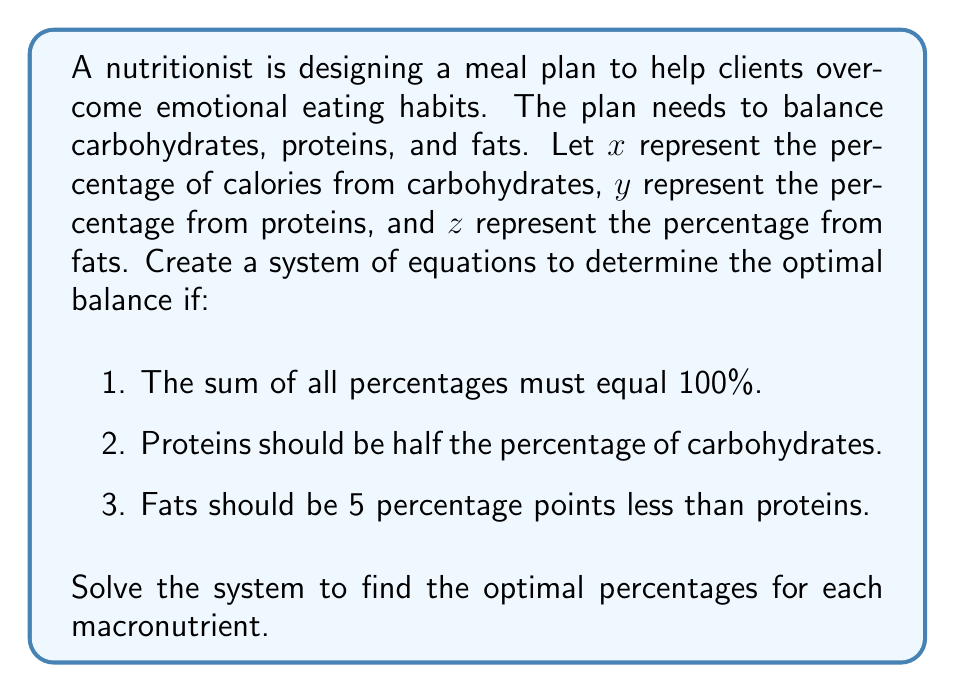Give your solution to this math problem. Let's approach this step-by-step:

1) First, let's translate the given information into equations:

   Equation 1: $x + y + z = 100$ (sum of percentages equals 100%)
   Equation 2: $y = \frac{1}{2}x$ (proteins are half of carbohydrates)
   Equation 3: $z = y - 5$ (fats are 5 percentage points less than proteins)

2) We now have a system of three equations with three unknowns. Let's solve it by substitution.

3) Substitute equation 2 into equation 3:
   $z = \frac{1}{2}x - 5$

4) Now substitute equations 2 and 3 into equation 1:
   $x + \frac{1}{2}x + (\frac{1}{2}x - 5) = 100$

5) Simplify:
   $x + \frac{1}{2}x + \frac{1}{2}x - 5 = 100$
   $2x - 5 = 100$

6) Solve for x:
   $2x = 105$
   $x = 52.5$

7) Now that we know x, we can find y using equation 2:
   $y = \frac{1}{2}(52.5) = 26.25$

8) And we can find z using equation 3:
   $z = 26.25 - 5 = 21.25$

9) Let's verify that these values satisfy all conditions:
   52.5 + 26.25 + 21.25 = 100
   26.25 is half of 52.5
   21.25 is 5 less than 26.25
Answer: The optimal balance of macronutrients is:
Carbohydrates: $52.5\%$
Proteins: $26.25\%$
Fats: $21.25\%$ 